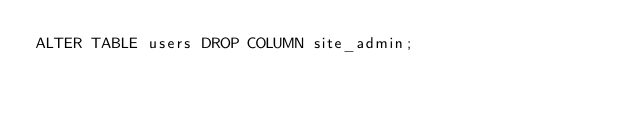<code> <loc_0><loc_0><loc_500><loc_500><_SQL_>ALTER TABLE users DROP COLUMN site_admin;
</code> 